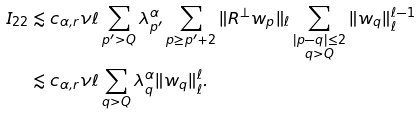Convert formula to latex. <formula><loc_0><loc_0><loc_500><loc_500>I _ { 2 2 } & \lesssim c _ { \alpha , r } \nu \ell \sum _ { p ^ { \prime } > Q } \lambda _ { p ^ { \prime } } ^ { \alpha } \sum _ { p \geq p ^ { \prime } + 2 } \| R ^ { \perp } w _ { p } \| _ { \ell } \sum _ { \substack { | p - q | \leq 2 \\ q > Q } } \| w _ { q } \| _ { \ell } ^ { \ell - 1 } \\ & \lesssim c _ { \alpha , r } \nu \ell \sum _ { q > Q } \lambda _ { q } ^ { \alpha } \| w _ { q } \| _ { \ell } ^ { \ell } .</formula> 